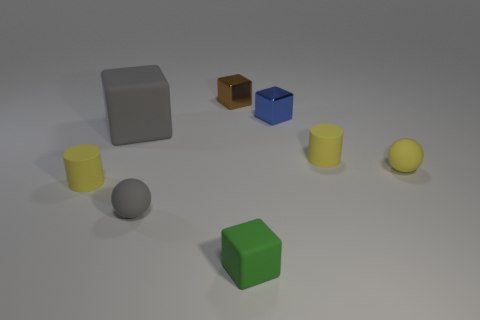Add 1 yellow shiny blocks. How many objects exist? 9 Subtract all gray cubes. How many cubes are left? 3 Subtract all gray cubes. How many cubes are left? 3 Subtract 1 blue cubes. How many objects are left? 7 Subtract all balls. How many objects are left? 6 Subtract 2 balls. How many balls are left? 0 Subtract all yellow blocks. Subtract all green spheres. How many blocks are left? 4 Subtract all cyan balls. How many blue blocks are left? 1 Subtract all small blue cubes. Subtract all tiny yellow things. How many objects are left? 4 Add 8 blue things. How many blue things are left? 9 